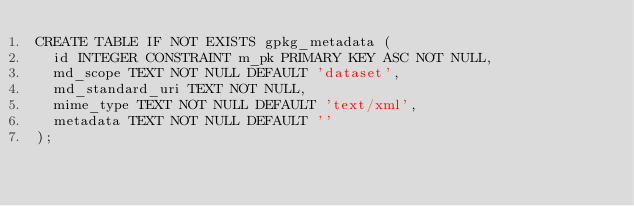Convert code to text. <code><loc_0><loc_0><loc_500><loc_500><_SQL_>CREATE TABLE IF NOT EXISTS gpkg_metadata (
  id INTEGER CONSTRAINT m_pk PRIMARY KEY ASC NOT NULL,
  md_scope TEXT NOT NULL DEFAULT 'dataset',
  md_standard_uri TEXT NOT NULL,
  mime_type TEXT NOT NULL DEFAULT 'text/xml',
  metadata TEXT NOT NULL DEFAULT ''
);
</code> 